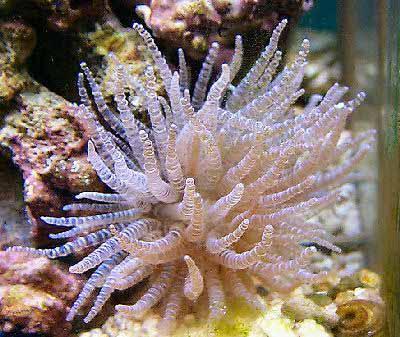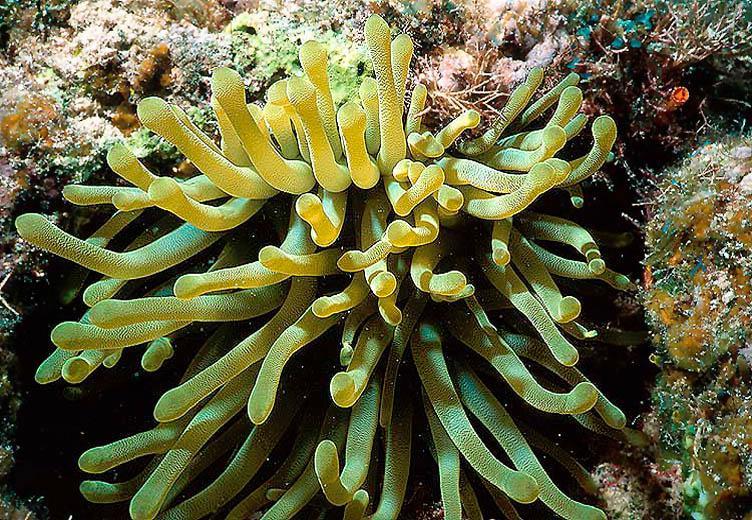The first image is the image on the left, the second image is the image on the right. For the images shown, is this caption "An image shows one white anemone with vivid purple dots at the end of its tendrils." true? Answer yes or no. No. 